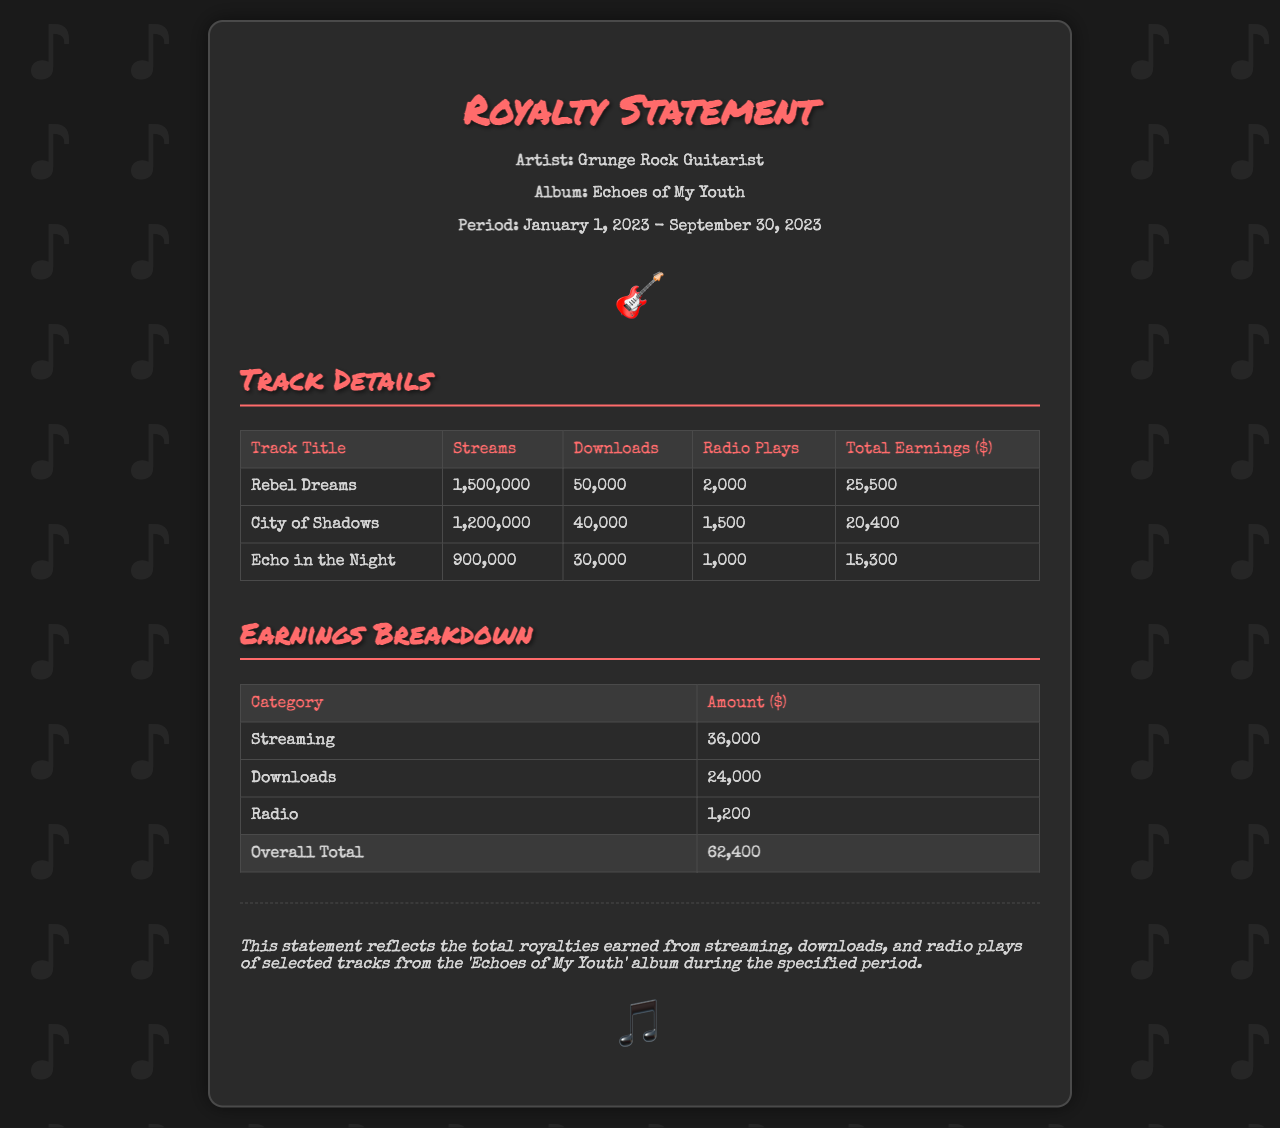what is the album title? The album title is specified in the header section of the document.
Answer: Echoes of My Youth how many streams did "Rebel Dreams" receive? The number of streams for "Rebel Dreams" is found in the track details table.
Answer: 1,500,000 what is the total earnings from downloads? The total earnings from downloads is listed in the earnings breakdown section.
Answer: 24,000 which track had the highest radio plays? This information can be deduced by comparing the radio plays in the track details table.
Answer: Rebel Dreams what is the overall total earnings? The overall total earnings are the final sum listed in the earnings breakdown section.
Answer: 62,400 what period does this royalty statement cover? The period is stated in the header information at the beginning of the document.
Answer: January 1, 2023 - September 30, 2023 how many tracks are detailed in the document? The number of tracks can be counted from the track details table.
Answer: 3 what is the streaming earnings amount? The streaming earnings amount is clearly stated in the earnings breakdown table.
Answer: 36,000 who is the artist? The artist's name is specified in the header section of the document.
Answer: Grunge Rock Guitarist 